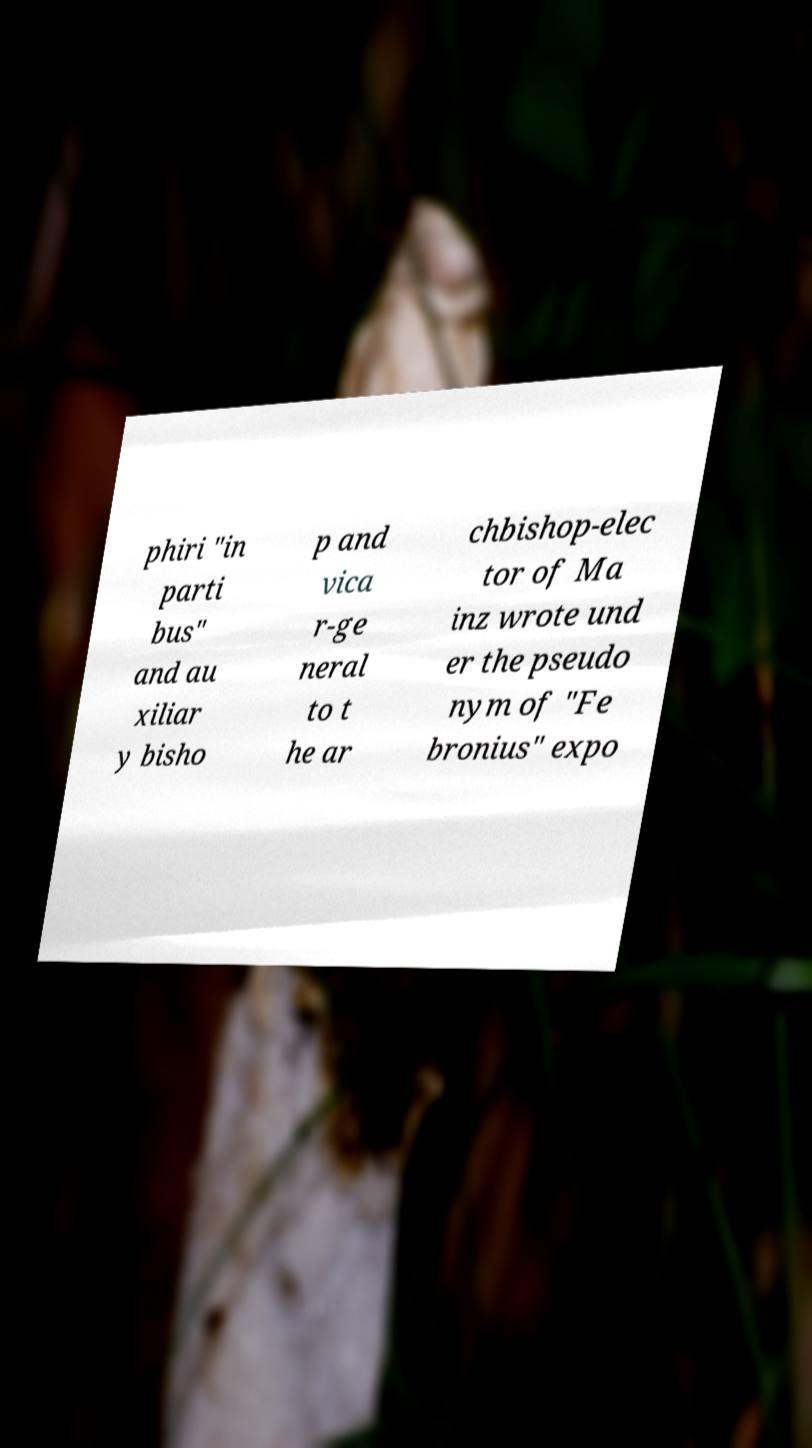There's text embedded in this image that I need extracted. Can you transcribe it verbatim? phiri "in parti bus" and au xiliar y bisho p and vica r-ge neral to t he ar chbishop-elec tor of Ma inz wrote und er the pseudo nym of "Fe bronius" expo 